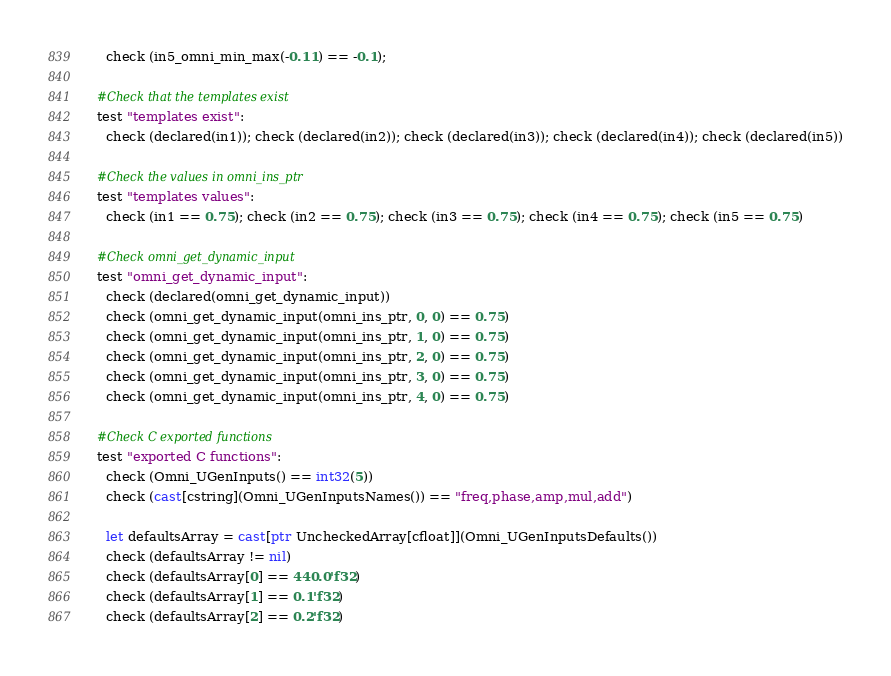<code> <loc_0><loc_0><loc_500><loc_500><_Nim_>    check (in5_omni_min_max(-0.11) == -0.1);

  #Check that the templates exist
  test "templates exist":
    check (declared(in1)); check (declared(in2)); check (declared(in3)); check (declared(in4)); check (declared(in5))

  #Check the values in omni_ins_ptr
  test "templates values":
    check (in1 == 0.75); check (in2 == 0.75); check (in3 == 0.75); check (in4 == 0.75); check (in5 == 0.75)
    
  #Check omni_get_dynamic_input
  test "omni_get_dynamic_input":
    check (declared(omni_get_dynamic_input))
    check (omni_get_dynamic_input(omni_ins_ptr, 0, 0) == 0.75)
    check (omni_get_dynamic_input(omni_ins_ptr, 1, 0) == 0.75)
    check (omni_get_dynamic_input(omni_ins_ptr, 2, 0) == 0.75)
    check (omni_get_dynamic_input(omni_ins_ptr, 3, 0) == 0.75)
    check (omni_get_dynamic_input(omni_ins_ptr, 4, 0) == 0.75)
  
  #Check C exported functions
  test "exported C functions":
    check (Omni_UGenInputs() == int32(5))
    check (cast[cstring](Omni_UGenInputsNames()) == "freq,phase,amp,mul,add")
    
    let defaultsArray = cast[ptr UncheckedArray[cfloat]](Omni_UGenInputsDefaults())
    check (defaultsArray != nil)
    check (defaultsArray[0] == 440.0'f32)
    check (defaultsArray[1] == 0.1'f32)
    check (defaultsArray[2] == 0.2'f32)</code> 